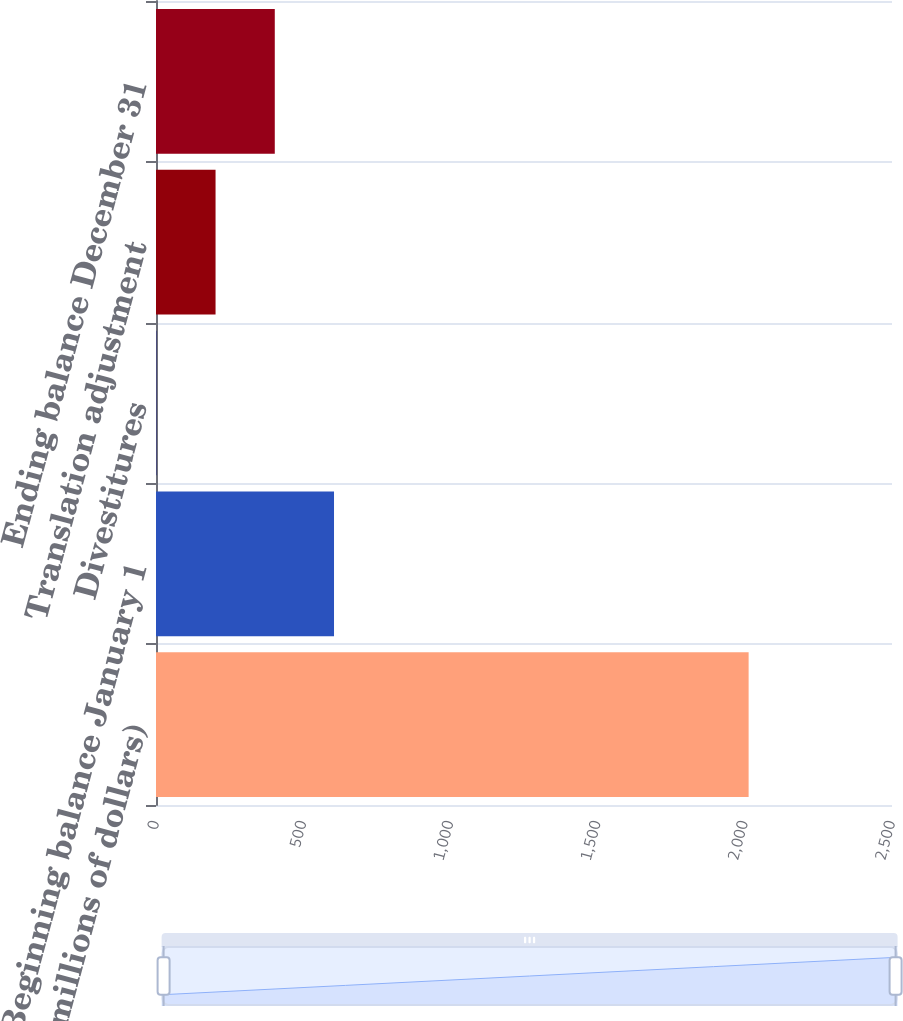Convert chart to OTSL. <chart><loc_0><loc_0><loc_500><loc_500><bar_chart><fcel>(millions of dollars)<fcel>Beginning balance January 1<fcel>Divestitures<fcel>Translation adjustment<fcel>Ending balance December 31<nl><fcel>2013<fcel>604.67<fcel>1.1<fcel>202.29<fcel>403.48<nl></chart> 